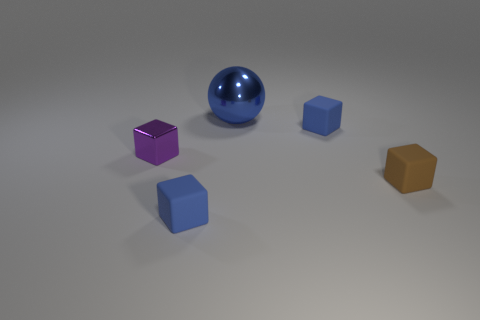There is a big metal object behind the blue matte block to the right of the large metal object; how many things are right of it?
Give a very brief answer. 2. How many things are to the left of the big ball and to the right of the metal block?
Give a very brief answer. 1. Is there any other thing that has the same material as the large ball?
Your answer should be very brief. Yes. Do the big sphere and the small purple object have the same material?
Ensure brevity in your answer.  Yes. What shape is the rubber object to the right of the blue cube behind the blue rubber block to the left of the big metallic ball?
Your answer should be very brief. Cube. Are there fewer blue objects that are to the left of the ball than small brown objects on the left side of the small metal block?
Offer a terse response. No. What is the shape of the tiny object that is on the right side of the small object behind the small metal cube?
Keep it short and to the point. Cube. Is there any other thing of the same color as the metal block?
Provide a succinct answer. No. How many blue things are either big metal balls or big blocks?
Offer a terse response. 1. Is the number of brown matte things that are behind the small brown rubber object less than the number of tiny shiny things?
Provide a short and direct response. Yes. 